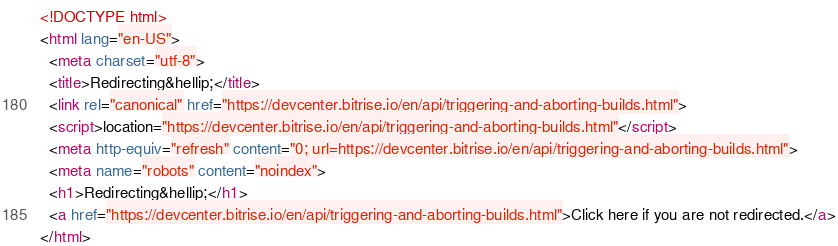<code> <loc_0><loc_0><loc_500><loc_500><_HTML_><!DOCTYPE html>
<html lang="en-US">
  <meta charset="utf-8">
  <title>Redirecting&hellip;</title>
  <link rel="canonical" href="https://devcenter.bitrise.io/en/api/triggering-and-aborting-builds.html">
  <script>location="https://devcenter.bitrise.io/en/api/triggering-and-aborting-builds.html"</script>
  <meta http-equiv="refresh" content="0; url=https://devcenter.bitrise.io/en/api/triggering-and-aborting-builds.html">
  <meta name="robots" content="noindex">
  <h1>Redirecting&hellip;</h1>
  <a href="https://devcenter.bitrise.io/en/api/triggering-and-aborting-builds.html">Click here if you are not redirected.</a>
</html></code> 